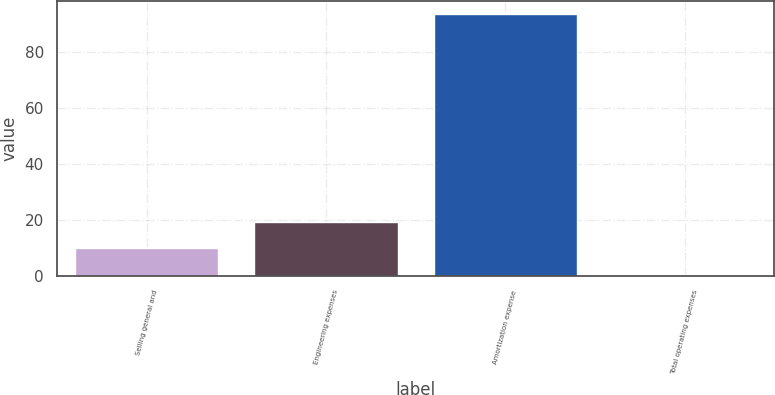<chart> <loc_0><loc_0><loc_500><loc_500><bar_chart><fcel>Selling general and<fcel>Engineering expenses<fcel>Amortization expense<fcel>Total operating expenses<nl><fcel>9.88<fcel>19.16<fcel>93.4<fcel>0.6<nl></chart> 